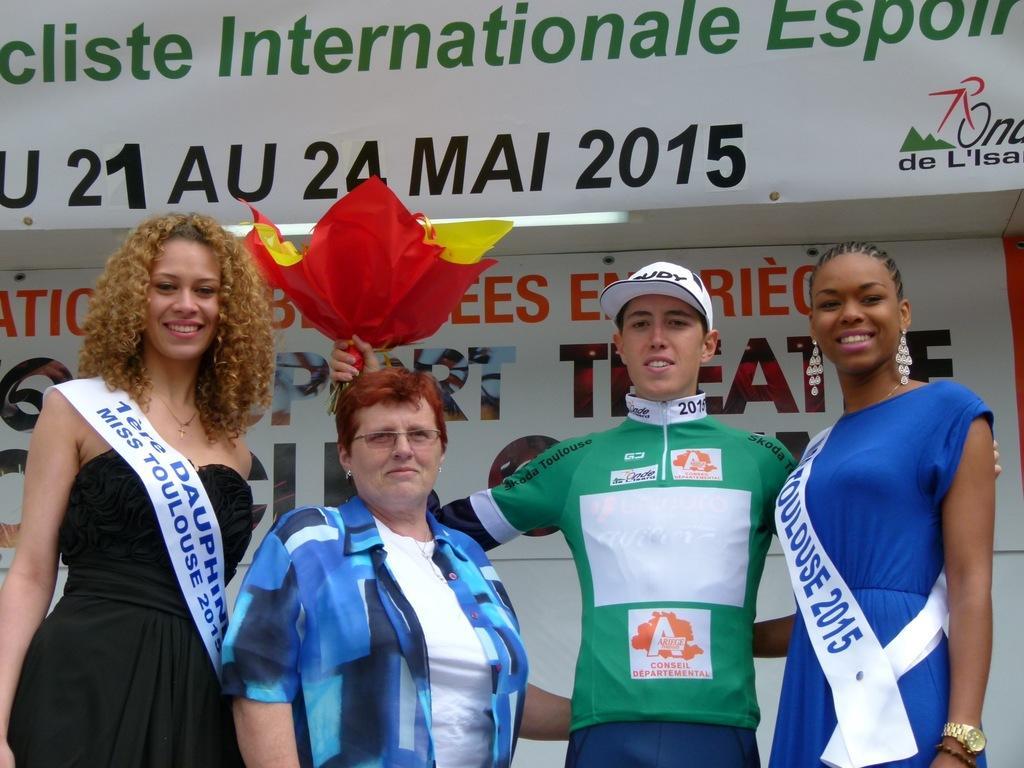Can you describe this image briefly? There are people in the center of the image, a woman holding a bouquet in her hand and there is a poster in the background area. 